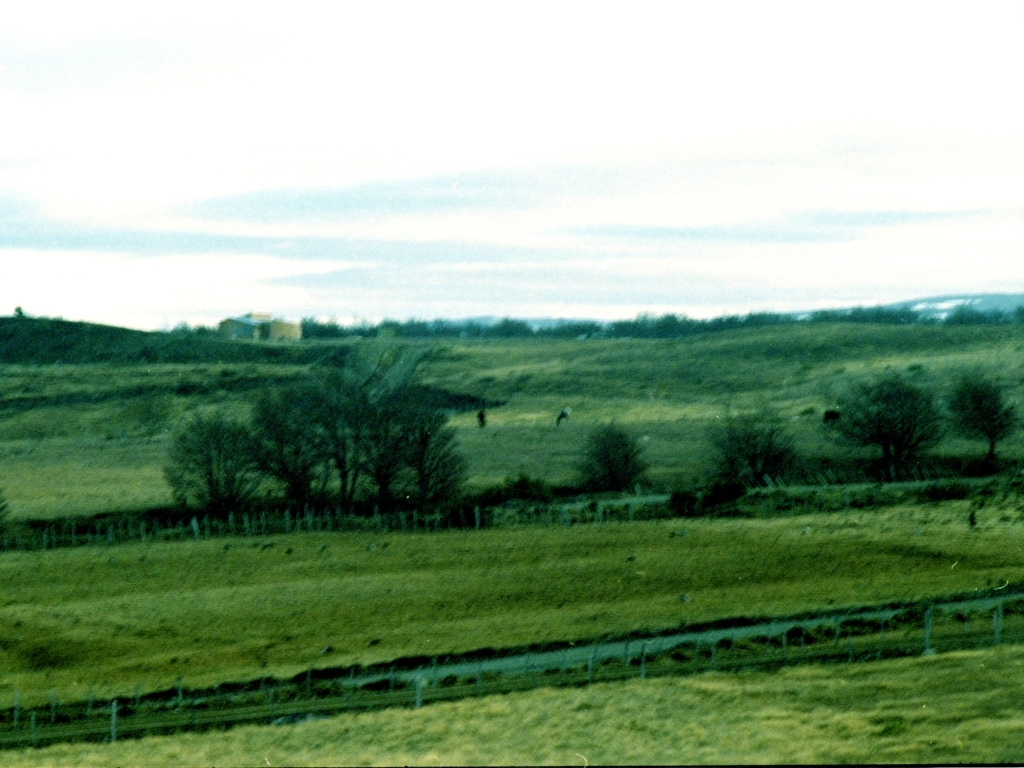Does the image have good sharpness? The image's sharpness is not optimal as the details are quite soft, especially in the background areas. Improving sharpness could bring out more details in the landscape, such as the textures of the grass and the definition of the trees and other features. 